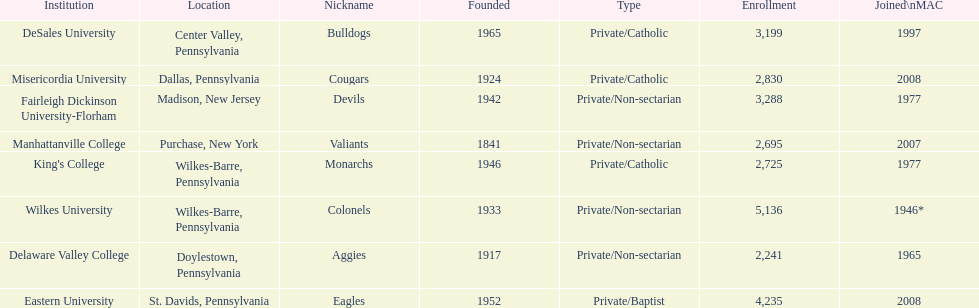Name each institution with enrollment numbers above 4,000? Eastern University, Wilkes University. 